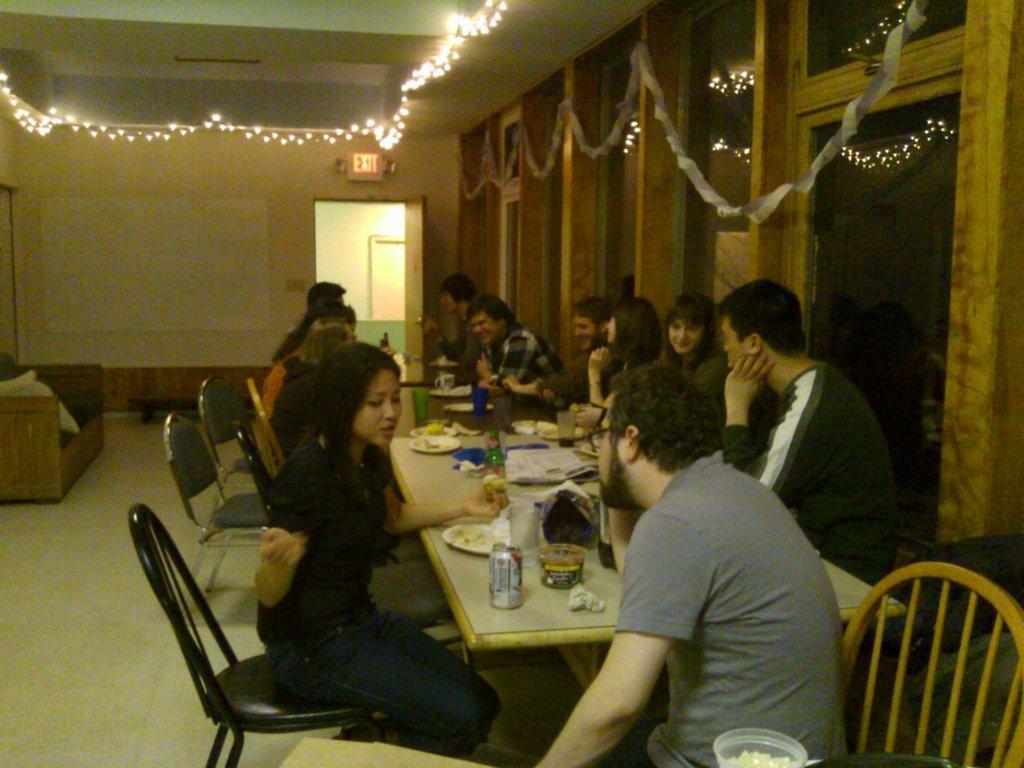Can you describe this image briefly? In this picture we can see many people are sitting and talking in front of the table. There are many item on the table like coke,plate,cups, glasses are on the table. And we can see chairs. To the left side there is sofa. And on the top there are lightnings. And to the right there is a doors with glasses. 